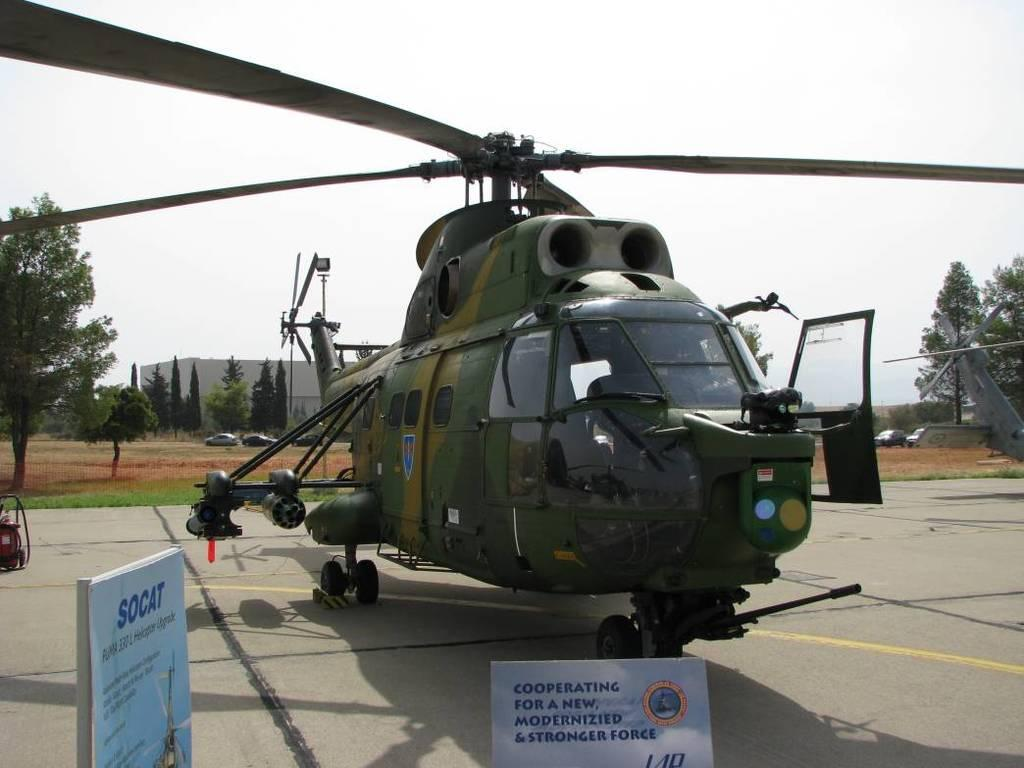<image>
Render a clear and concise summary of the photo. the word socat is on the white sign 